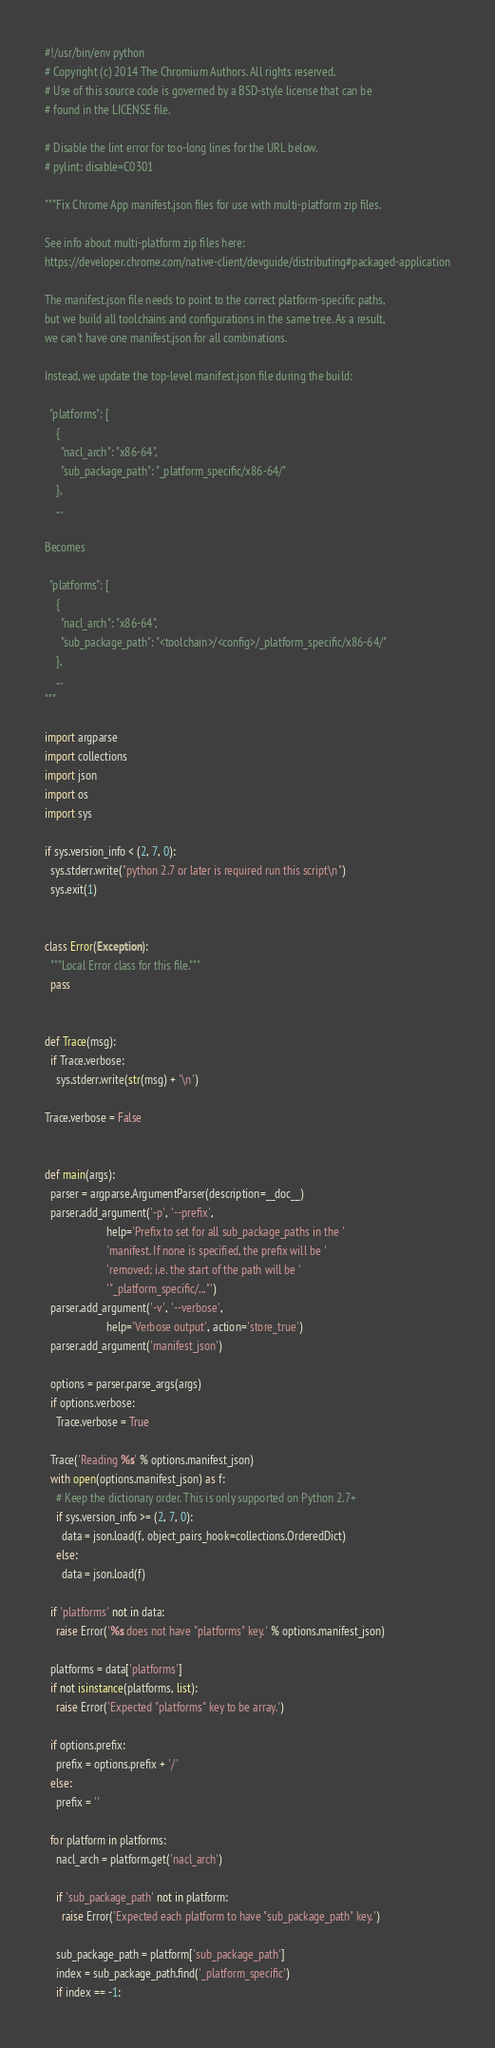Convert code to text. <code><loc_0><loc_0><loc_500><loc_500><_Python_>#!/usr/bin/env python
# Copyright (c) 2014 The Chromium Authors. All rights reserved.
# Use of this source code is governed by a BSD-style license that can be
# found in the LICENSE file.

# Disable the lint error for too-long lines for the URL below.
# pylint: disable=C0301

"""Fix Chrome App manifest.json files for use with multi-platform zip files.

See info about multi-platform zip files here:
https://developer.chrome.com/native-client/devguide/distributing#packaged-application

The manifest.json file needs to point to the correct platform-specific paths,
but we build all toolchains and configurations in the same tree. As a result,
we can't have one manifest.json for all combinations.

Instead, we update the top-level manifest.json file during the build:

  "platforms": [
    {
      "nacl_arch": "x86-64",
      "sub_package_path": "_platform_specific/x86-64/"
    },
    ...

Becomes

  "platforms": [
    {
      "nacl_arch": "x86-64",
      "sub_package_path": "<toolchain>/<config>/_platform_specific/x86-64/"
    },
    ...
"""

import argparse
import collections
import json
import os
import sys

if sys.version_info < (2, 7, 0):
  sys.stderr.write("python 2.7 or later is required run this script\n")
  sys.exit(1)


class Error(Exception):
  """Local Error class for this file."""
  pass


def Trace(msg):
  if Trace.verbose:
    sys.stderr.write(str(msg) + '\n')

Trace.verbose = False


def main(args):
  parser = argparse.ArgumentParser(description=__doc__)
  parser.add_argument('-p', '--prefix',
                      help='Prefix to set for all sub_package_paths in the '
                      'manifest. If none is specified, the prefix will be '
                      'removed; i.e. the start of the path will be '
                      '"_platform_specific/..."')
  parser.add_argument('-v', '--verbose',
                      help='Verbose output', action='store_true')
  parser.add_argument('manifest_json')

  options = parser.parse_args(args)
  if options.verbose:
    Trace.verbose = True

  Trace('Reading %s' % options.manifest_json)
  with open(options.manifest_json) as f:
    # Keep the dictionary order. This is only supported on Python 2.7+
    if sys.version_info >= (2, 7, 0):
      data = json.load(f, object_pairs_hook=collections.OrderedDict)
    else:
      data = json.load(f)

  if 'platforms' not in data:
    raise Error('%s does not have "platforms" key.' % options.manifest_json)

  platforms = data['platforms']
  if not isinstance(platforms, list):
    raise Error('Expected "platforms" key to be array.')

  if options.prefix:
    prefix = options.prefix + '/'
  else:
    prefix = ''

  for platform in platforms:
    nacl_arch = platform.get('nacl_arch')

    if 'sub_package_path' not in platform:
      raise Error('Expected each platform to have "sub_package_path" key.')

    sub_package_path = platform['sub_package_path']
    index = sub_package_path.find('_platform_specific')
    if index == -1:</code> 